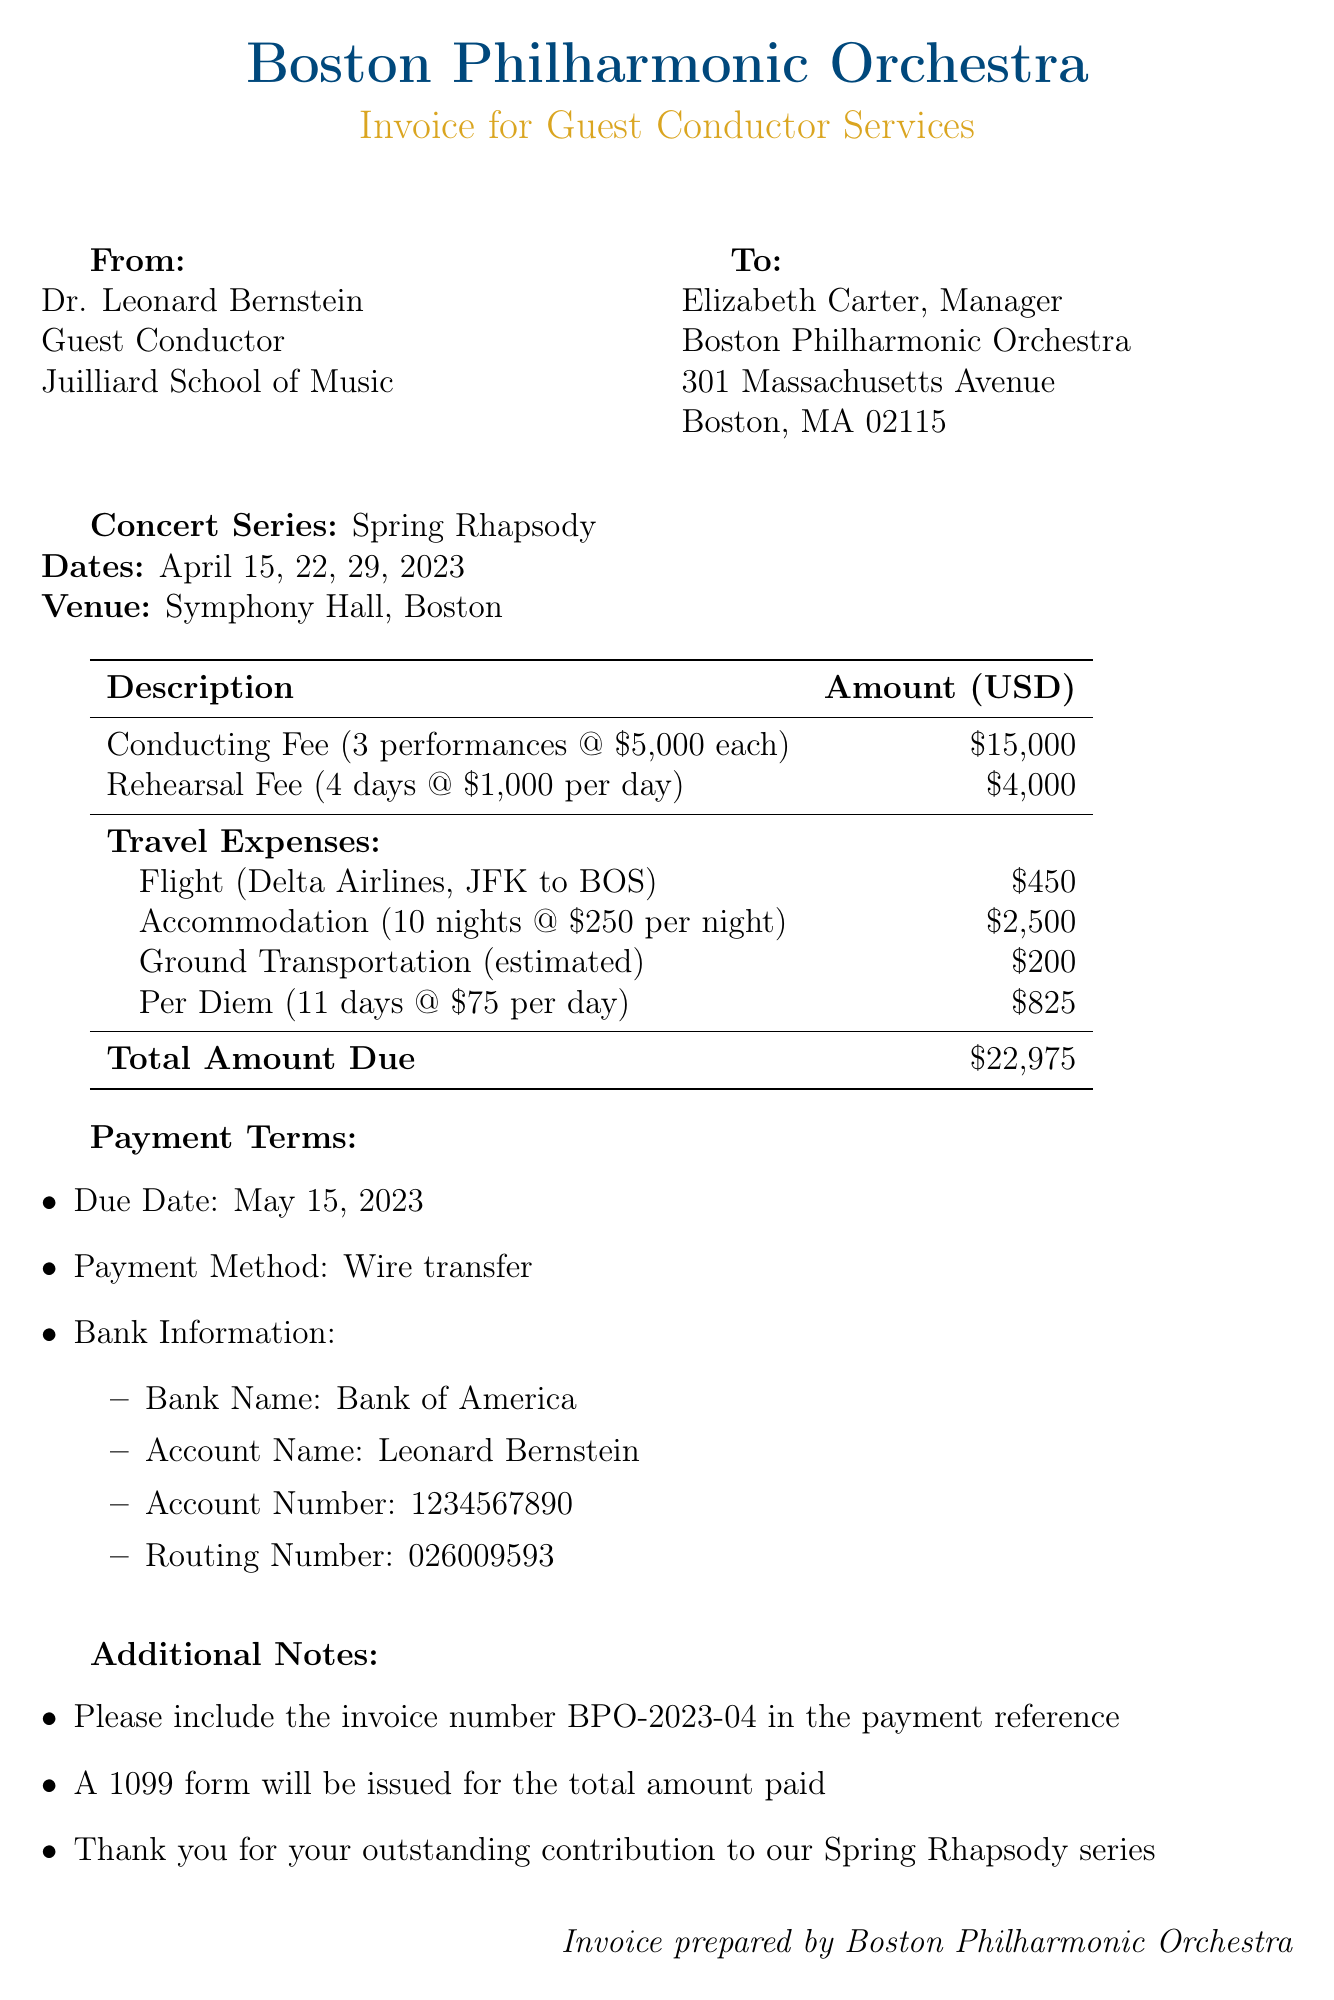What is the name of the guest conductor? The document specifies the name of the guest conductor, which is Dr. Leonard Bernstein.
Answer: Dr. Leonard Bernstein What is the total conducting fee? The document indicates that the total conducting fee for the performances is $15,000.
Answer: $15,000 How many performances are included in the conducting fee? The document states that there are 3 performances that contribute to the conducting fee.
Answer: 3 What is the daily rate for per diem? The document mentions the daily rate for per diem, which is $75.
Answer: $75 When is the payment due date? The due date for the payment is clearly stated in the document as May 15, 2023.
Answer: May 15, 2023 What is the total amount due? The total amount due, as mentioned in the document, is $22,975.
Answer: $22,975 How many nights of accommodation are provided? The document specifies that the accommodation for the conductor covers a total of 10 nights.
Answer: 10 nights What is the airline used for the flight? The document indicates that the airline for the flight is Delta Airlines.
Answer: Delta Airlines What method of payment is mentioned? The payment method mentioned in the document is wire transfer.
Answer: Wire transfer 